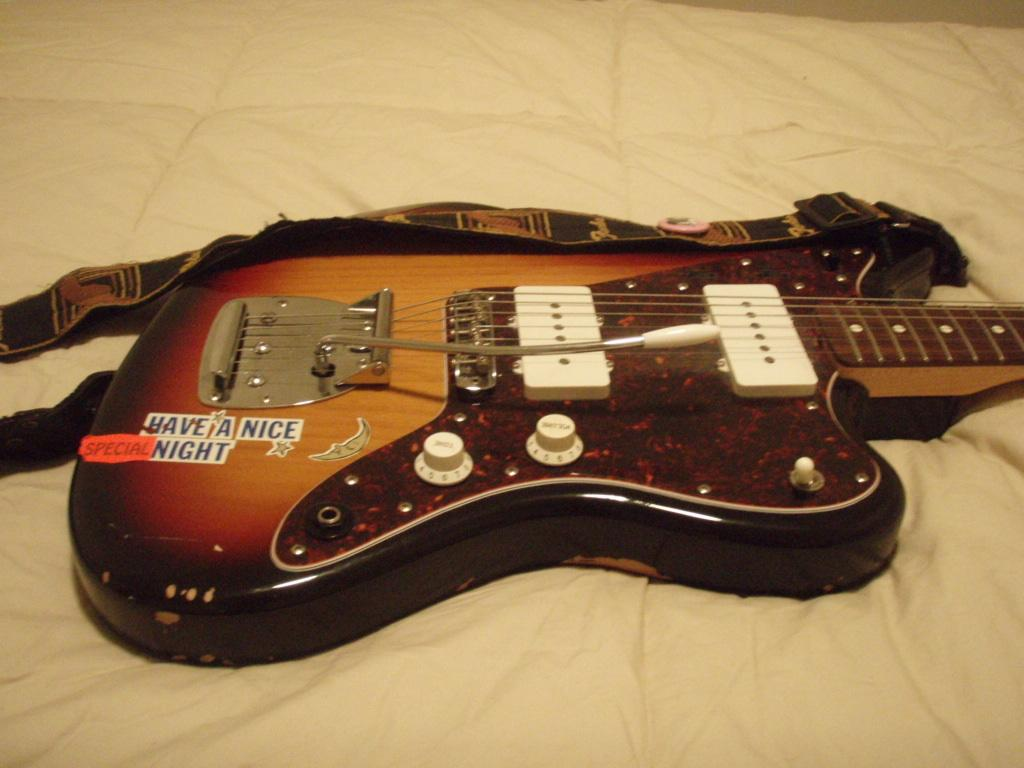What musical instrument is present in the image? There is a guitar in the image. What type of strings does the guitar have? The facts provided do not specify the type of strings on the guitar. Is the guitar being played in the image? The facts provided do not indicate whether the guitar is being played or not. What color is the guitar? The facts provided do not specify the color of the guitar. How does the guitar express anger in the image? The guitar does not express anger in the image, as it is an inanimate object and cannot display emotions. 